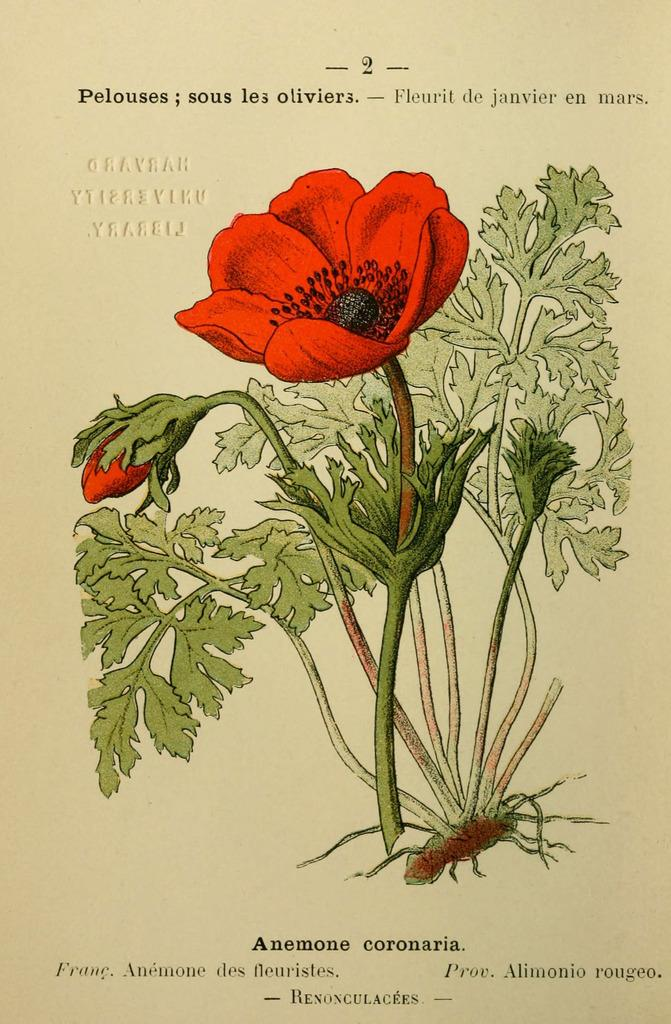What is the main subject of the painting in the image? The main subject of the painting in the image is flowers and plants. What color are the flowers in the painting? The flowers in the painting are red in color. Is there any text or writing visible in the image? Yes, there is text or writing visible in the image. Can you tell me how many doctors are present in the painting? There are no doctors present in the painting; it features a painting of flowers and plants. What type of house is depicted in the painting? There is no house depicted in the painting; it features a painting of flowers and plants. 